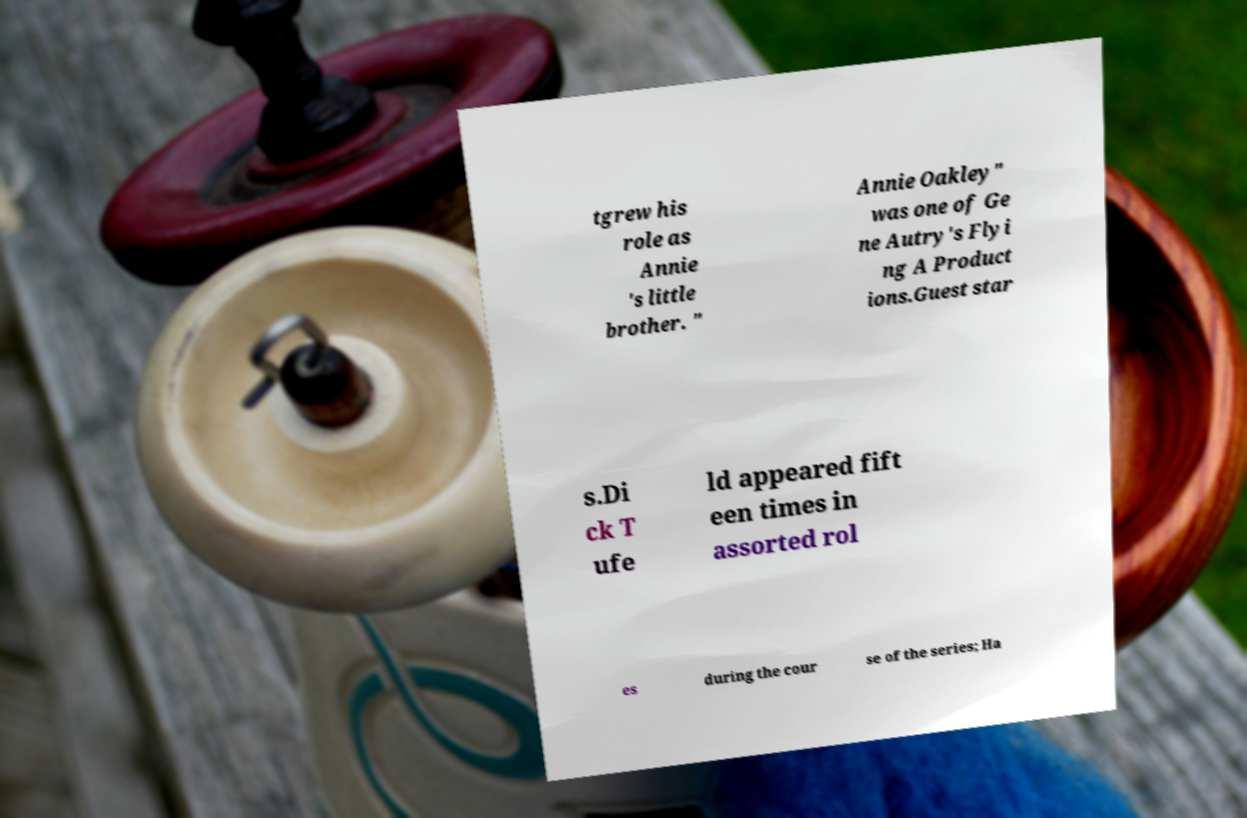For documentation purposes, I need the text within this image transcribed. Could you provide that? tgrew his role as Annie 's little brother. " Annie Oakley" was one of Ge ne Autry's Flyi ng A Product ions.Guest star s.Di ck T ufe ld appeared fift een times in assorted rol es during the cour se of the series; Ha 